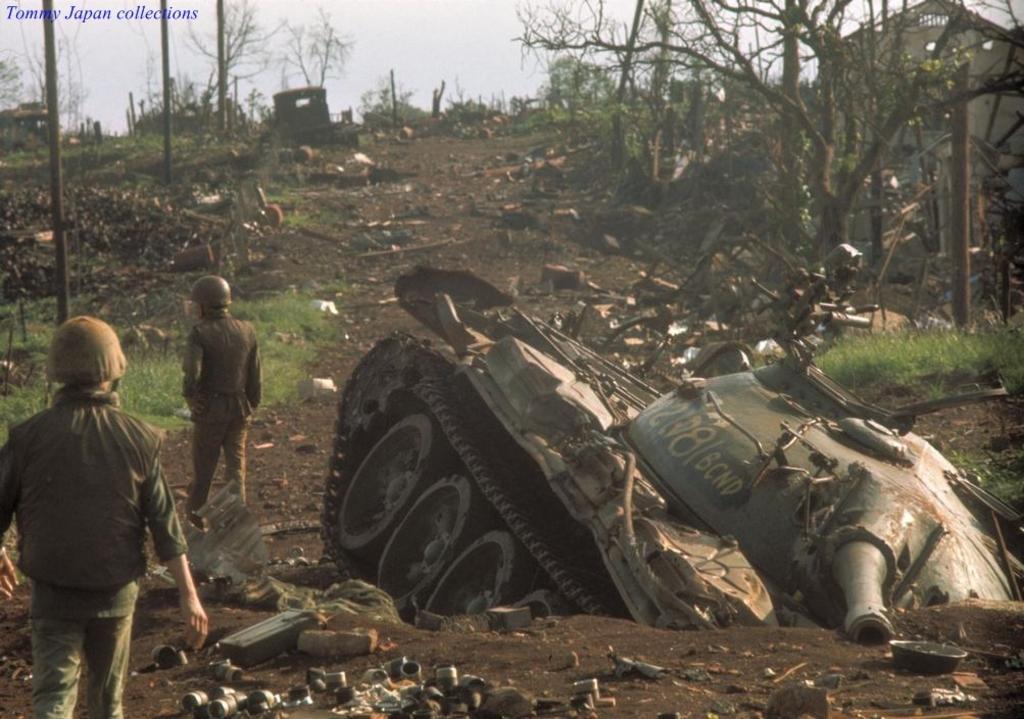What type of vehicle is broken on the right side of the image? There is a broken Panzer on the right side of the image. What can be seen on the left side of the image? There are people on the left side of the image. What type of vegetation is present on the right side of the image? There are trees on the right side of the image. What type of vegetation is present on the left side of the image? There are trees on the left side of the image. What type of dinner is being served on the left side of the image? There is no dinner present in the image; it features a broken Panzer and people on the left side. Can you describe the wool clothing worn by the people on the left side of the image? There is no wool clothing mentioned or visible in the image; the people are not described in detail. 